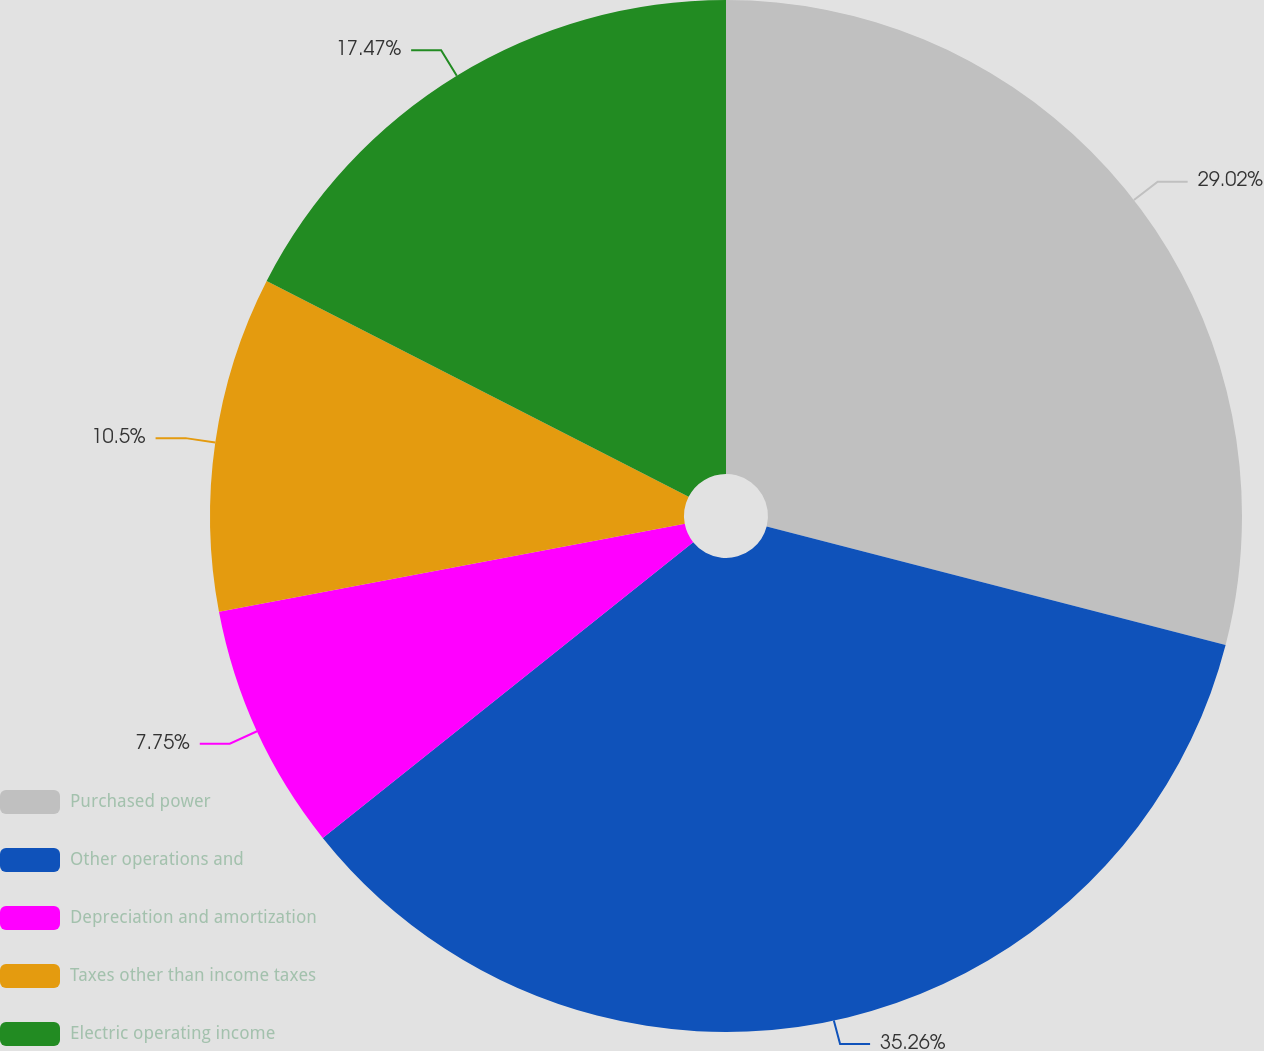<chart> <loc_0><loc_0><loc_500><loc_500><pie_chart><fcel>Purchased power<fcel>Other operations and<fcel>Depreciation and amortization<fcel>Taxes other than income taxes<fcel>Electric operating income<nl><fcel>29.02%<fcel>35.25%<fcel>7.75%<fcel>10.5%<fcel>17.47%<nl></chart> 